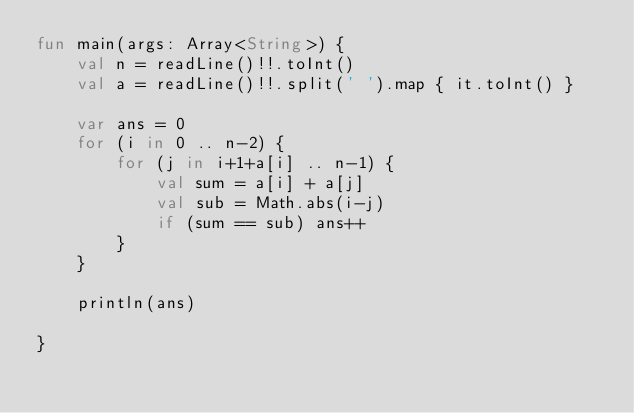Convert code to text. <code><loc_0><loc_0><loc_500><loc_500><_Kotlin_>fun main(args: Array<String>) {
    val n = readLine()!!.toInt()
    val a = readLine()!!.split(' ').map { it.toInt() }

    var ans = 0
    for (i in 0 .. n-2) {
        for (j in i+1+a[i] .. n-1) {
            val sum = a[i] + a[j]
            val sub = Math.abs(i-j)
            if (sum == sub) ans++
        }
    }

    println(ans)

}
</code> 